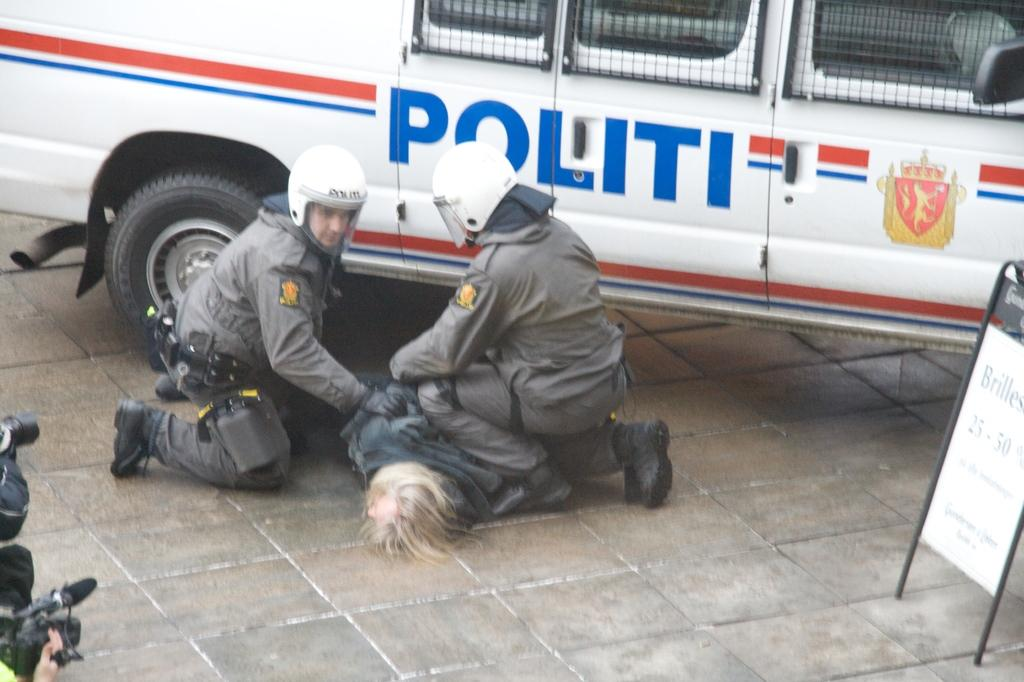Provide a one-sentence caption for the provided image. Two men have another man on the ground next to a Politi van. 